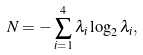Convert formula to latex. <formula><loc_0><loc_0><loc_500><loc_500>N = - \sum _ { i = 1 } ^ { 4 } \lambda _ { i } \log _ { 2 } \lambda _ { i } ,</formula> 